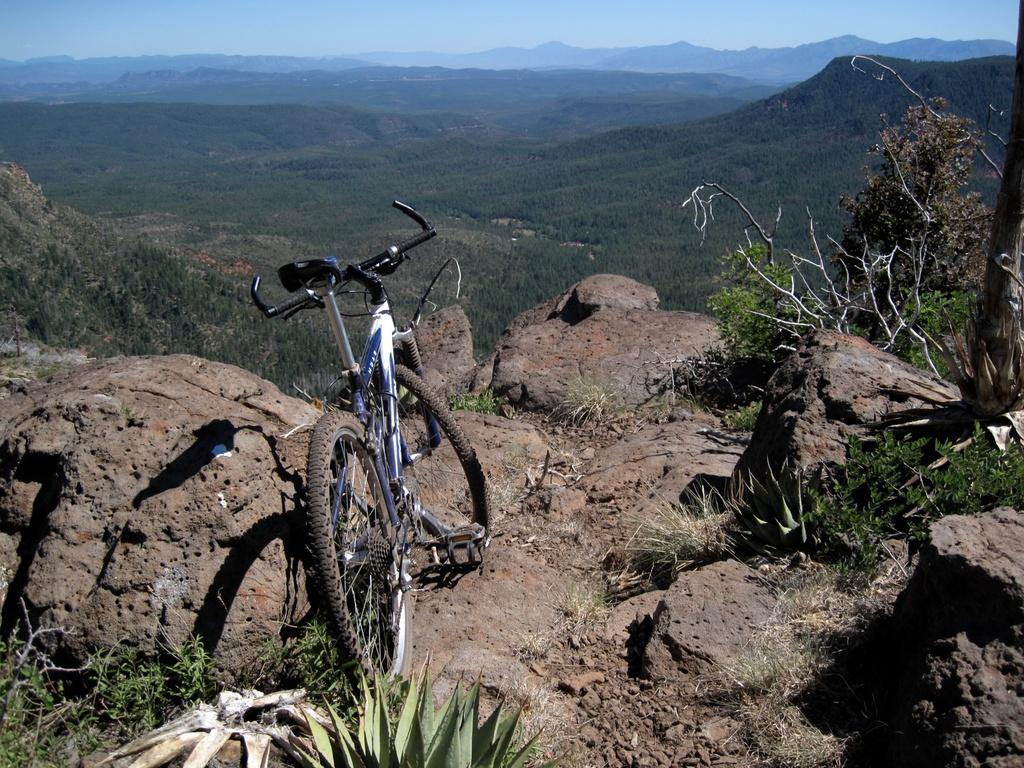What is the main object in the image? There is a bicycle in the image. What can be seen on the right side of the bicycle? There are rocks and plants on the right side of the bicycle. What is visible in front of the bicycle? There are hills visible in front of the bicycle. What is visible in the background of the image? The sky is visible in the image. What type of protest is happening near the bicycle in the image? There is no protest visible in the image; it only features a bicycle, rocks, plants, hills, and the sky. 